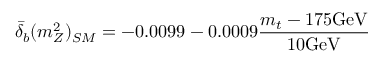Convert formula to latex. <formula><loc_0><loc_0><loc_500><loc_500>{ \bar { \delta } } _ { b } ( m _ { Z } ^ { 2 } ) _ { S M } = - 0 . 0 0 9 9 - 0 . 0 0 0 9 { \frac { m _ { t } - 1 7 5 G e V } { 1 0 G e V } }</formula> 